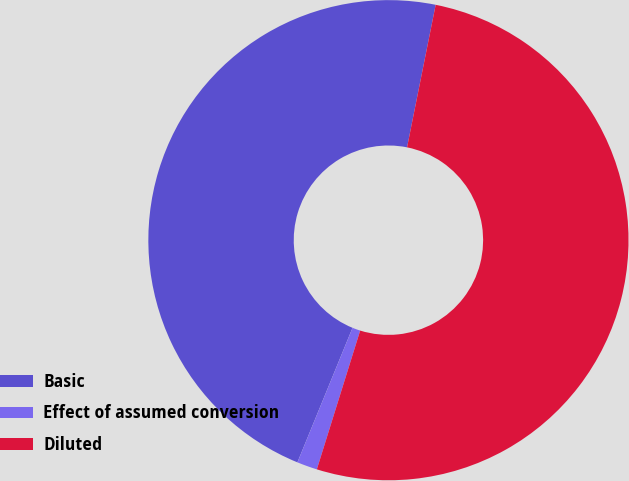<chart> <loc_0><loc_0><loc_500><loc_500><pie_chart><fcel>Basic<fcel>Effect of assumed conversion<fcel>Diluted<nl><fcel>46.96%<fcel>1.37%<fcel>51.66%<nl></chart> 